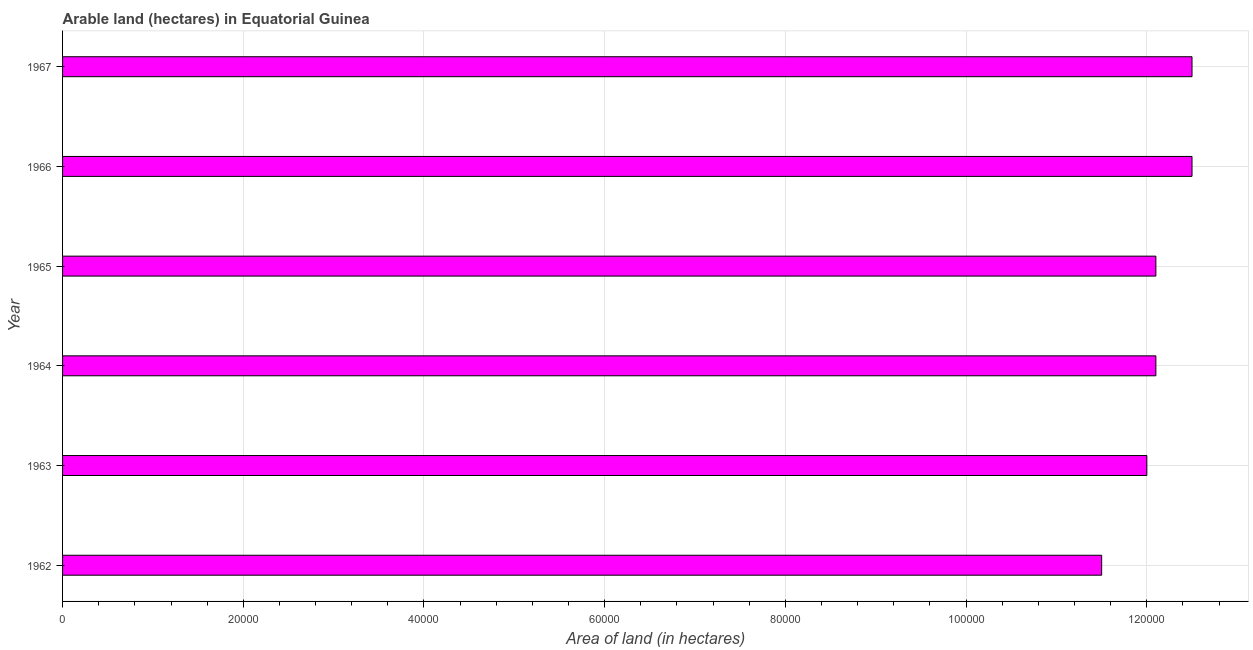Does the graph contain any zero values?
Your response must be concise. No. What is the title of the graph?
Your answer should be compact. Arable land (hectares) in Equatorial Guinea. What is the label or title of the X-axis?
Make the answer very short. Area of land (in hectares). What is the label or title of the Y-axis?
Ensure brevity in your answer.  Year. What is the area of land in 1964?
Your answer should be compact. 1.21e+05. Across all years, what is the maximum area of land?
Give a very brief answer. 1.25e+05. Across all years, what is the minimum area of land?
Keep it short and to the point. 1.15e+05. In which year was the area of land maximum?
Your answer should be very brief. 1966. What is the sum of the area of land?
Your response must be concise. 7.27e+05. What is the difference between the area of land in 1962 and 1964?
Give a very brief answer. -6000. What is the average area of land per year?
Give a very brief answer. 1.21e+05. What is the median area of land?
Ensure brevity in your answer.  1.21e+05. Do a majority of the years between 1965 and 1966 (inclusive) have area of land greater than 60000 hectares?
Your answer should be very brief. Yes. Is the area of land in 1965 less than that in 1966?
Your response must be concise. Yes. Is the difference between the area of land in 1963 and 1967 greater than the difference between any two years?
Your answer should be very brief. No. What is the difference between the highest and the lowest area of land?
Keep it short and to the point. 10000. In how many years, is the area of land greater than the average area of land taken over all years?
Ensure brevity in your answer.  2. What is the difference between two consecutive major ticks on the X-axis?
Offer a very short reply. 2.00e+04. What is the Area of land (in hectares) of 1962?
Keep it short and to the point. 1.15e+05. What is the Area of land (in hectares) in 1963?
Your answer should be compact. 1.20e+05. What is the Area of land (in hectares) of 1964?
Offer a very short reply. 1.21e+05. What is the Area of land (in hectares) in 1965?
Ensure brevity in your answer.  1.21e+05. What is the Area of land (in hectares) in 1966?
Offer a terse response. 1.25e+05. What is the Area of land (in hectares) in 1967?
Offer a very short reply. 1.25e+05. What is the difference between the Area of land (in hectares) in 1962 and 1963?
Keep it short and to the point. -5000. What is the difference between the Area of land (in hectares) in 1962 and 1964?
Provide a short and direct response. -6000. What is the difference between the Area of land (in hectares) in 1962 and 1965?
Make the answer very short. -6000. What is the difference between the Area of land (in hectares) in 1963 and 1964?
Your answer should be very brief. -1000. What is the difference between the Area of land (in hectares) in 1963 and 1965?
Your response must be concise. -1000. What is the difference between the Area of land (in hectares) in 1963 and 1966?
Offer a very short reply. -5000. What is the difference between the Area of land (in hectares) in 1963 and 1967?
Offer a very short reply. -5000. What is the difference between the Area of land (in hectares) in 1964 and 1965?
Your answer should be compact. 0. What is the difference between the Area of land (in hectares) in 1964 and 1966?
Provide a succinct answer. -4000. What is the difference between the Area of land (in hectares) in 1964 and 1967?
Your response must be concise. -4000. What is the difference between the Area of land (in hectares) in 1965 and 1966?
Your answer should be very brief. -4000. What is the difference between the Area of land (in hectares) in 1965 and 1967?
Provide a short and direct response. -4000. What is the difference between the Area of land (in hectares) in 1966 and 1967?
Offer a terse response. 0. What is the ratio of the Area of land (in hectares) in 1962 to that in 1963?
Provide a short and direct response. 0.96. What is the ratio of the Area of land (in hectares) in 1962 to that in 1964?
Offer a very short reply. 0.95. What is the ratio of the Area of land (in hectares) in 1962 to that in 1965?
Ensure brevity in your answer.  0.95. What is the ratio of the Area of land (in hectares) in 1962 to that in 1966?
Make the answer very short. 0.92. What is the ratio of the Area of land (in hectares) in 1962 to that in 1967?
Offer a terse response. 0.92. What is the ratio of the Area of land (in hectares) in 1963 to that in 1964?
Ensure brevity in your answer.  0.99. What is the ratio of the Area of land (in hectares) in 1963 to that in 1965?
Give a very brief answer. 0.99. What is the ratio of the Area of land (in hectares) in 1963 to that in 1967?
Your answer should be compact. 0.96. What is the ratio of the Area of land (in hectares) in 1964 to that in 1965?
Keep it short and to the point. 1. What is the ratio of the Area of land (in hectares) in 1964 to that in 1966?
Offer a very short reply. 0.97. What is the ratio of the Area of land (in hectares) in 1964 to that in 1967?
Provide a succinct answer. 0.97. What is the ratio of the Area of land (in hectares) in 1965 to that in 1967?
Your answer should be compact. 0.97. 